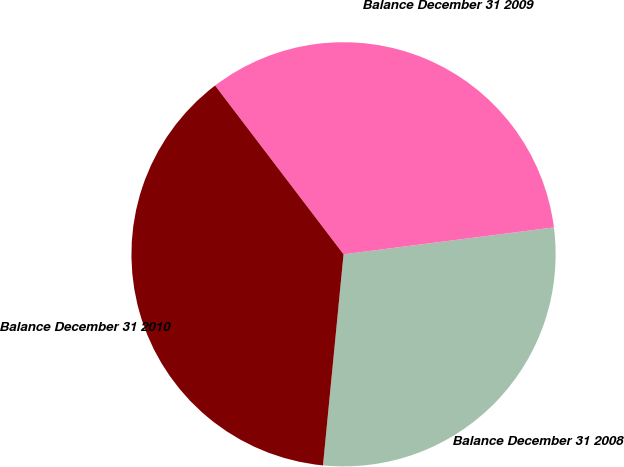<chart> <loc_0><loc_0><loc_500><loc_500><pie_chart><fcel>Balance December 31 2008<fcel>Balance December 31 2009<fcel>Balance December 31 2010<nl><fcel>28.57%<fcel>33.33%<fcel>38.1%<nl></chart> 